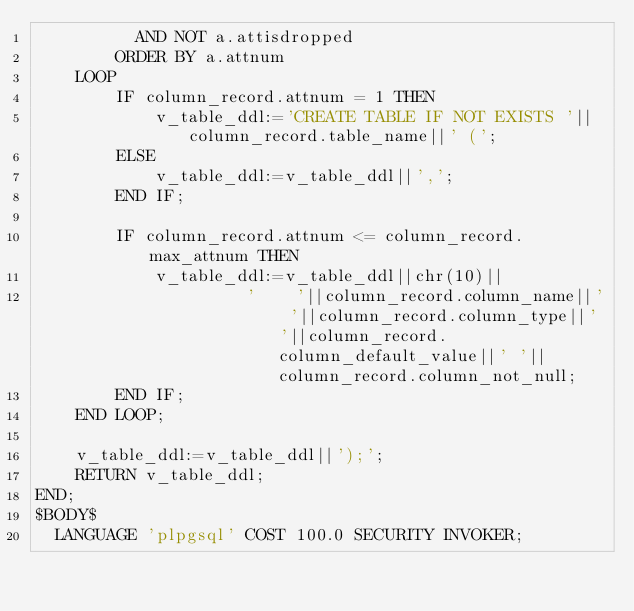Convert code to text. <code><loc_0><loc_0><loc_500><loc_500><_SQL_>          AND NOT a.attisdropped
        ORDER BY a.attnum
    LOOP
        IF column_record.attnum = 1 THEN
            v_table_ddl:='CREATE TABLE IF NOT EXISTS '||column_record.table_name||' (';
        ELSE
            v_table_ddl:=v_table_ddl||',';
        END IF;

        IF column_record.attnum <= column_record.max_attnum THEN
            v_table_ddl:=v_table_ddl||chr(10)||
                     '    '||column_record.column_name||' '||column_record.column_type||' '||column_record.column_default_value||' '||column_record.column_not_null;
        END IF;
    END LOOP;

    v_table_ddl:=v_table_ddl||');';
    RETURN v_table_ddl;
END;
$BODY$
  LANGUAGE 'plpgsql' COST 100.0 SECURITY INVOKER;</code> 